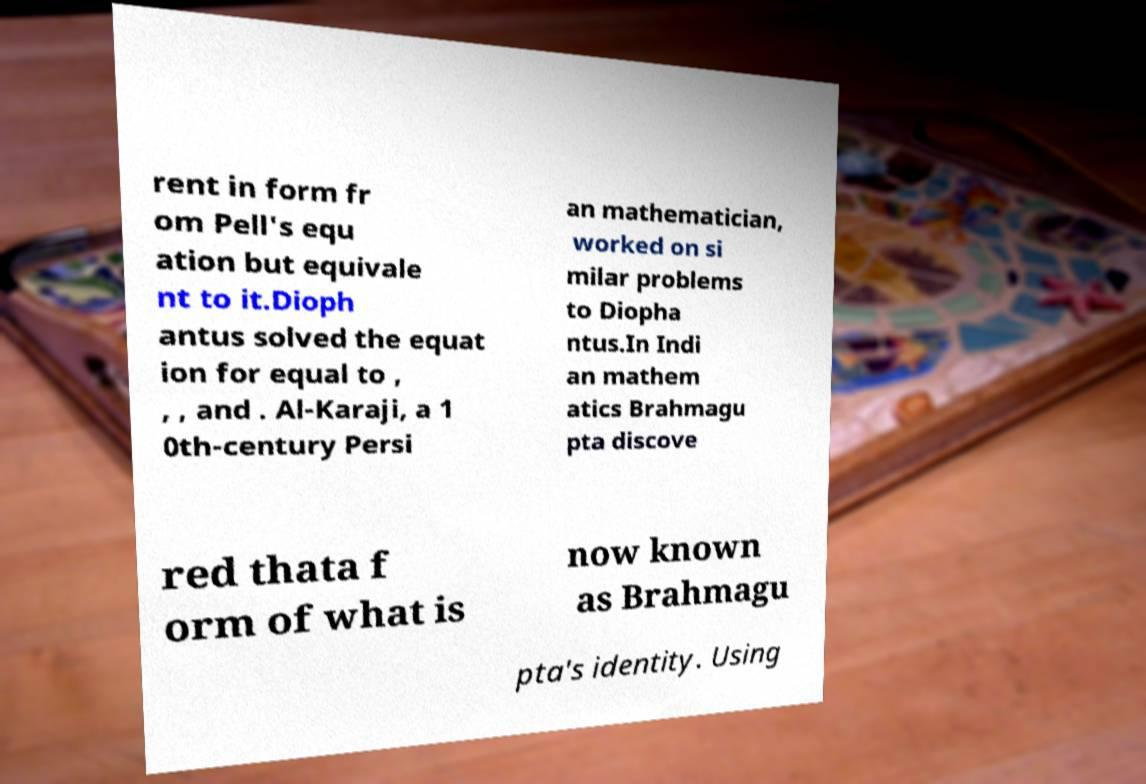Can you read and provide the text displayed in the image?This photo seems to have some interesting text. Can you extract and type it out for me? rent in form fr om Pell's equ ation but equivale nt to it.Dioph antus solved the equat ion for equal to , , , and . Al-Karaji, a 1 0th-century Persi an mathematician, worked on si milar problems to Diopha ntus.In Indi an mathem atics Brahmagu pta discove red thata f orm of what is now known as Brahmagu pta's identity. Using 